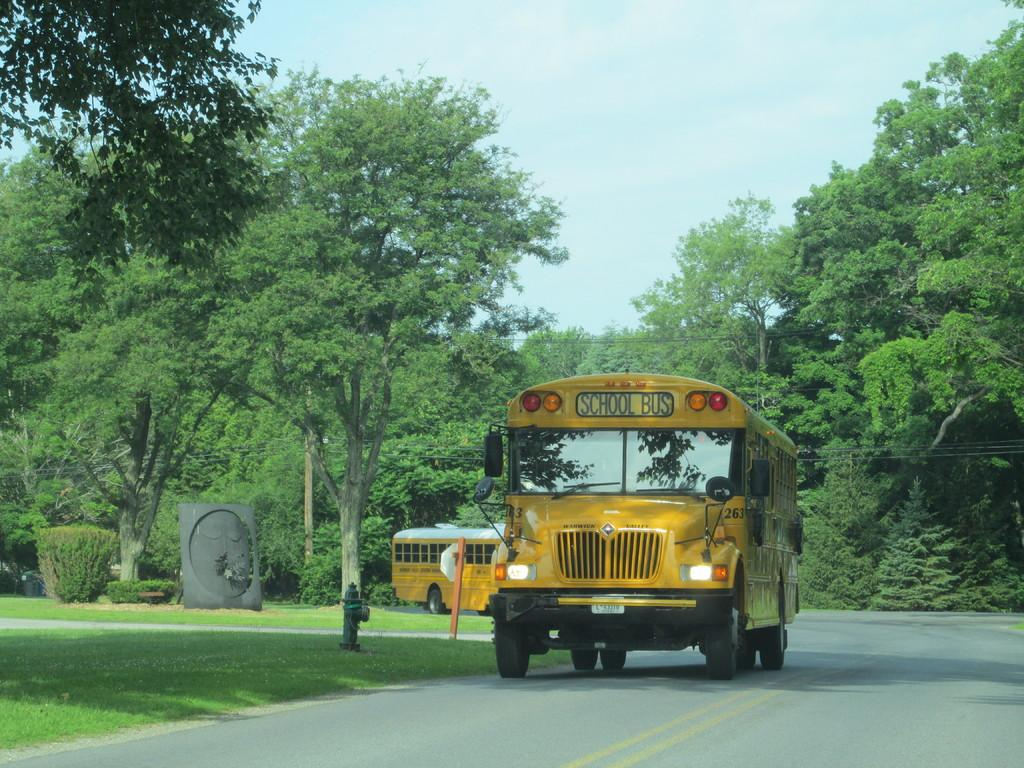What type of vehicles can be seen on the road in the image? There are buses on the road in the image. What type of vegetation is visible in the image? There is grass and trees visible in the image. What object is present for fire safety in the image? A hydrant is present in the image. What type of artwork is visible in the image? There is a sculpture in the image. What type of structures can be seen in the image? Poles are visible in the image. What is visible in the background of the image? The sky is visible in the background of the image. What type of knot is being tied by the leg in the image? There is no knot or leg present in the image. What is the weather like in the image? The provided facts do not mention the weather, so it cannot be determined from the image. 